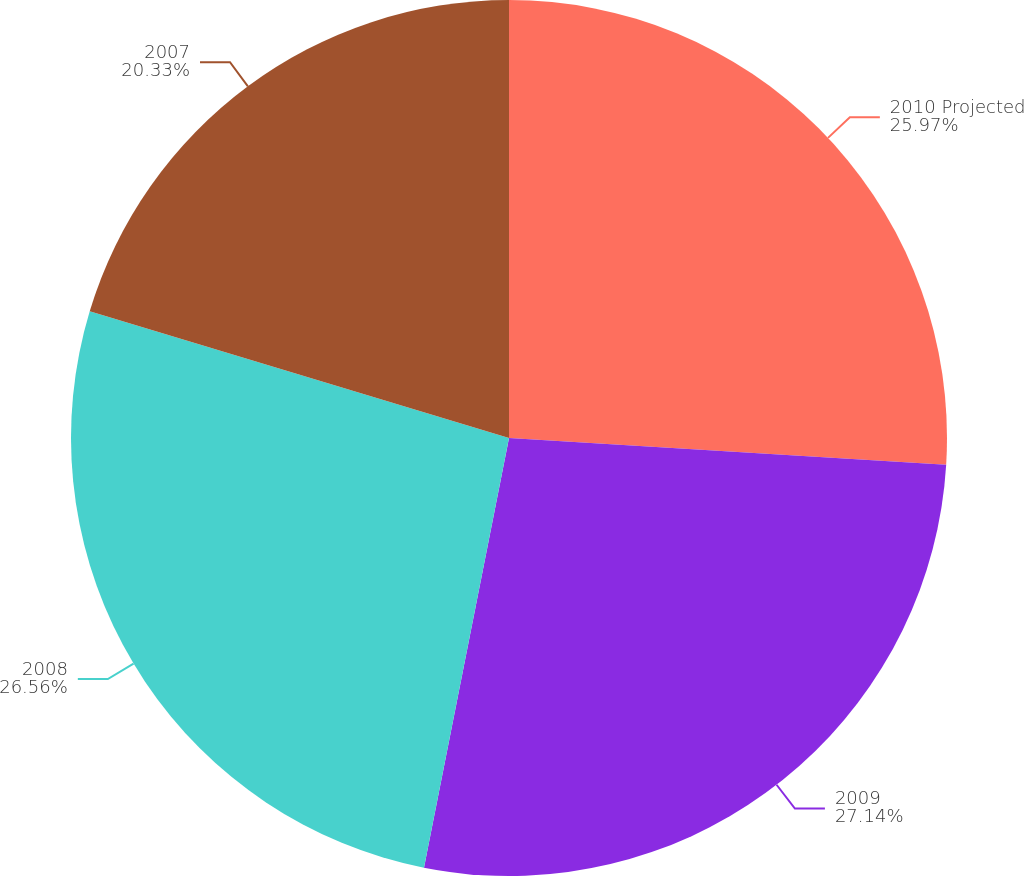Convert chart. <chart><loc_0><loc_0><loc_500><loc_500><pie_chart><fcel>2010 Projected<fcel>2009<fcel>2008<fcel>2007<nl><fcel>25.97%<fcel>27.14%<fcel>26.56%<fcel>20.33%<nl></chart> 